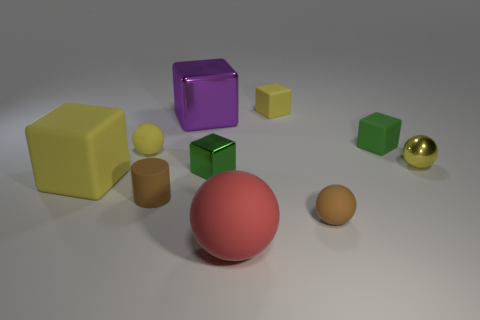There is a small sphere that is the same color as the rubber cylinder; what is it made of?
Make the answer very short. Rubber. There is a rubber block that is the same color as the small shiny cube; what is its size?
Ensure brevity in your answer.  Small. Do the big block in front of the small green metal thing and the tiny metallic ball have the same color?
Keep it short and to the point. Yes. What number of other things are there of the same shape as the large yellow rubber object?
Your answer should be very brief. 4. There is a large matte thing left of the red sphere; does it have the same shape as the small brown thing on the left side of the large red rubber ball?
Ensure brevity in your answer.  No. What is the material of the brown cylinder?
Your answer should be compact. Rubber. What is the block that is left of the big purple block made of?
Provide a short and direct response. Rubber. Is there anything else that is the same color as the large metallic block?
Ensure brevity in your answer.  No. There is a red ball that is the same material as the tiny yellow cube; what size is it?
Ensure brevity in your answer.  Large. What number of large objects are brown rubber cylinders or green objects?
Offer a very short reply. 0. 